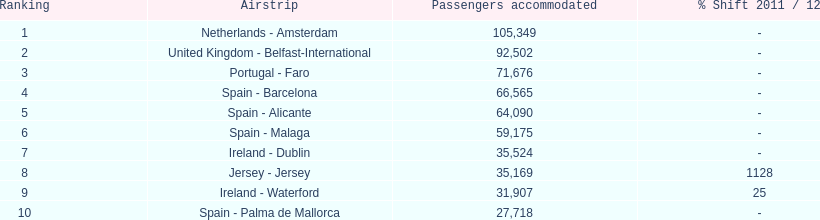What are the numbers of passengers handled along the different routes in the airport? 105,349, 92,502, 71,676, 66,565, 64,090, 59,175, 35,524, 35,169, 31,907, 27,718. Of these routes, which handles less than 30,000 passengers? Spain - Palma de Mallorca. 